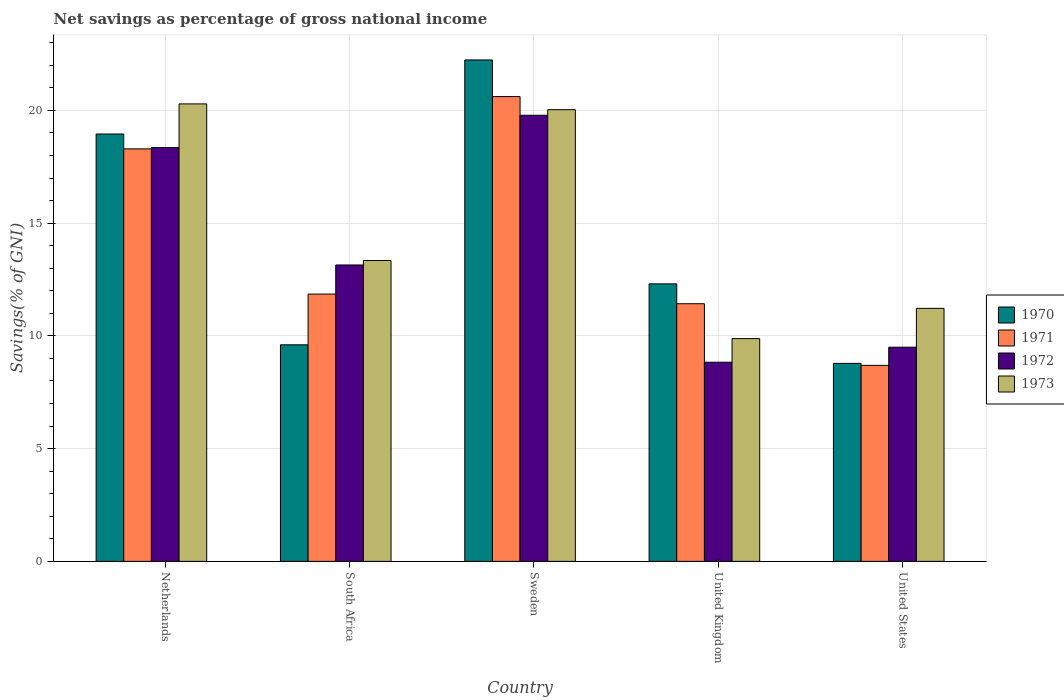How many groups of bars are there?
Keep it short and to the point. 5. Are the number of bars per tick equal to the number of legend labels?
Offer a very short reply. Yes. How many bars are there on the 5th tick from the left?
Ensure brevity in your answer.  4. What is the label of the 3rd group of bars from the left?
Provide a succinct answer. Sweden. In how many cases, is the number of bars for a given country not equal to the number of legend labels?
Make the answer very short. 0. What is the total savings in 1973 in Netherlands?
Keep it short and to the point. 20.29. Across all countries, what is the maximum total savings in 1970?
Ensure brevity in your answer.  22.24. Across all countries, what is the minimum total savings in 1973?
Your answer should be compact. 9.88. What is the total total savings in 1973 in the graph?
Ensure brevity in your answer.  74.76. What is the difference between the total savings in 1970 in South Africa and that in United Kingdom?
Ensure brevity in your answer.  -2.7. What is the difference between the total savings in 1971 in United States and the total savings in 1970 in Netherlands?
Provide a succinct answer. -10.26. What is the average total savings in 1970 per country?
Your answer should be very brief. 14.38. What is the difference between the total savings of/in 1970 and total savings of/in 1972 in United States?
Your answer should be compact. -0.72. In how many countries, is the total savings in 1971 greater than 2 %?
Make the answer very short. 5. What is the ratio of the total savings in 1970 in Sweden to that in United States?
Your answer should be very brief. 2.53. Is the total savings in 1973 in Sweden less than that in United States?
Your answer should be very brief. No. Is the difference between the total savings in 1970 in Sweden and United Kingdom greater than the difference between the total savings in 1972 in Sweden and United Kingdom?
Your answer should be very brief. No. What is the difference between the highest and the second highest total savings in 1972?
Your response must be concise. -1.43. What is the difference between the highest and the lowest total savings in 1973?
Ensure brevity in your answer.  10.41. In how many countries, is the total savings in 1973 greater than the average total savings in 1973 taken over all countries?
Provide a succinct answer. 2. Is the sum of the total savings in 1971 in Netherlands and United Kingdom greater than the maximum total savings in 1973 across all countries?
Keep it short and to the point. Yes. Is it the case that in every country, the sum of the total savings in 1973 and total savings in 1971 is greater than the sum of total savings in 1970 and total savings in 1972?
Your answer should be compact. No. What does the 3rd bar from the left in South Africa represents?
Ensure brevity in your answer.  1972. What does the 3rd bar from the right in Sweden represents?
Provide a succinct answer. 1971. Is it the case that in every country, the sum of the total savings in 1970 and total savings in 1973 is greater than the total savings in 1971?
Provide a short and direct response. Yes. Are all the bars in the graph horizontal?
Your response must be concise. No. How many countries are there in the graph?
Offer a very short reply. 5. What is the difference between two consecutive major ticks on the Y-axis?
Provide a short and direct response. 5. Does the graph contain any zero values?
Keep it short and to the point. No. Where does the legend appear in the graph?
Give a very brief answer. Center right. What is the title of the graph?
Make the answer very short. Net savings as percentage of gross national income. Does "1983" appear as one of the legend labels in the graph?
Your answer should be very brief. No. What is the label or title of the Y-axis?
Give a very brief answer. Savings(% of GNI). What is the Savings(% of GNI) in 1970 in Netherlands?
Give a very brief answer. 18.95. What is the Savings(% of GNI) in 1971 in Netherlands?
Give a very brief answer. 18.29. What is the Savings(% of GNI) in 1972 in Netherlands?
Provide a succinct answer. 18.35. What is the Savings(% of GNI) in 1973 in Netherlands?
Make the answer very short. 20.29. What is the Savings(% of GNI) in 1970 in South Africa?
Make the answer very short. 9.6. What is the Savings(% of GNI) of 1971 in South Africa?
Ensure brevity in your answer.  11.85. What is the Savings(% of GNI) in 1972 in South Africa?
Offer a terse response. 13.14. What is the Savings(% of GNI) of 1973 in South Africa?
Ensure brevity in your answer.  13.34. What is the Savings(% of GNI) in 1970 in Sweden?
Provide a succinct answer. 22.24. What is the Savings(% of GNI) in 1971 in Sweden?
Your answer should be compact. 20.61. What is the Savings(% of GNI) of 1972 in Sweden?
Keep it short and to the point. 19.78. What is the Savings(% of GNI) of 1973 in Sweden?
Keep it short and to the point. 20.03. What is the Savings(% of GNI) of 1970 in United Kingdom?
Your answer should be compact. 12.31. What is the Savings(% of GNI) in 1971 in United Kingdom?
Your answer should be compact. 11.43. What is the Savings(% of GNI) of 1972 in United Kingdom?
Provide a succinct answer. 8.83. What is the Savings(% of GNI) in 1973 in United Kingdom?
Give a very brief answer. 9.88. What is the Savings(% of GNI) in 1970 in United States?
Give a very brief answer. 8.78. What is the Savings(% of GNI) of 1971 in United States?
Your response must be concise. 8.69. What is the Savings(% of GNI) of 1972 in United States?
Offer a very short reply. 9.5. What is the Savings(% of GNI) of 1973 in United States?
Offer a very short reply. 11.22. Across all countries, what is the maximum Savings(% of GNI) of 1970?
Your response must be concise. 22.24. Across all countries, what is the maximum Savings(% of GNI) of 1971?
Provide a succinct answer. 20.61. Across all countries, what is the maximum Savings(% of GNI) of 1972?
Your response must be concise. 19.78. Across all countries, what is the maximum Savings(% of GNI) in 1973?
Your response must be concise. 20.29. Across all countries, what is the minimum Savings(% of GNI) of 1970?
Make the answer very short. 8.78. Across all countries, what is the minimum Savings(% of GNI) in 1971?
Give a very brief answer. 8.69. Across all countries, what is the minimum Savings(% of GNI) in 1972?
Provide a succinct answer. 8.83. Across all countries, what is the minimum Savings(% of GNI) in 1973?
Keep it short and to the point. 9.88. What is the total Savings(% of GNI) in 1970 in the graph?
Keep it short and to the point. 71.88. What is the total Savings(% of GNI) in 1971 in the graph?
Provide a short and direct response. 70.88. What is the total Savings(% of GNI) in 1972 in the graph?
Provide a succinct answer. 69.61. What is the total Savings(% of GNI) of 1973 in the graph?
Offer a very short reply. 74.76. What is the difference between the Savings(% of GNI) of 1970 in Netherlands and that in South Africa?
Keep it short and to the point. 9.35. What is the difference between the Savings(% of GNI) of 1971 in Netherlands and that in South Africa?
Your response must be concise. 6.44. What is the difference between the Savings(% of GNI) in 1972 in Netherlands and that in South Africa?
Give a very brief answer. 5.21. What is the difference between the Savings(% of GNI) in 1973 in Netherlands and that in South Africa?
Give a very brief answer. 6.95. What is the difference between the Savings(% of GNI) of 1970 in Netherlands and that in Sweden?
Your response must be concise. -3.28. What is the difference between the Savings(% of GNI) in 1971 in Netherlands and that in Sweden?
Offer a very short reply. -2.32. What is the difference between the Savings(% of GNI) in 1972 in Netherlands and that in Sweden?
Make the answer very short. -1.43. What is the difference between the Savings(% of GNI) of 1973 in Netherlands and that in Sweden?
Offer a very short reply. 0.26. What is the difference between the Savings(% of GNI) of 1970 in Netherlands and that in United Kingdom?
Provide a succinct answer. 6.65. What is the difference between the Savings(% of GNI) in 1971 in Netherlands and that in United Kingdom?
Offer a terse response. 6.87. What is the difference between the Savings(% of GNI) in 1972 in Netherlands and that in United Kingdom?
Give a very brief answer. 9.52. What is the difference between the Savings(% of GNI) of 1973 in Netherlands and that in United Kingdom?
Offer a very short reply. 10.41. What is the difference between the Savings(% of GNI) in 1970 in Netherlands and that in United States?
Provide a short and direct response. 10.17. What is the difference between the Savings(% of GNI) in 1971 in Netherlands and that in United States?
Your answer should be very brief. 9.6. What is the difference between the Savings(% of GNI) of 1972 in Netherlands and that in United States?
Offer a very short reply. 8.85. What is the difference between the Savings(% of GNI) of 1973 in Netherlands and that in United States?
Your answer should be compact. 9.07. What is the difference between the Savings(% of GNI) in 1970 in South Africa and that in Sweden?
Ensure brevity in your answer.  -12.63. What is the difference between the Savings(% of GNI) of 1971 in South Africa and that in Sweden?
Provide a short and direct response. -8.76. What is the difference between the Savings(% of GNI) of 1972 in South Africa and that in Sweden?
Give a very brief answer. -6.64. What is the difference between the Savings(% of GNI) in 1973 in South Africa and that in Sweden?
Your response must be concise. -6.69. What is the difference between the Savings(% of GNI) in 1970 in South Africa and that in United Kingdom?
Offer a very short reply. -2.7. What is the difference between the Savings(% of GNI) of 1971 in South Africa and that in United Kingdom?
Your answer should be very brief. 0.43. What is the difference between the Savings(% of GNI) of 1972 in South Africa and that in United Kingdom?
Your response must be concise. 4.31. What is the difference between the Savings(% of GNI) of 1973 in South Africa and that in United Kingdom?
Make the answer very short. 3.46. What is the difference between the Savings(% of GNI) in 1970 in South Africa and that in United States?
Provide a succinct answer. 0.82. What is the difference between the Savings(% of GNI) of 1971 in South Africa and that in United States?
Your answer should be compact. 3.16. What is the difference between the Savings(% of GNI) of 1972 in South Africa and that in United States?
Keep it short and to the point. 3.65. What is the difference between the Savings(% of GNI) in 1973 in South Africa and that in United States?
Your response must be concise. 2.12. What is the difference between the Savings(% of GNI) of 1970 in Sweden and that in United Kingdom?
Provide a short and direct response. 9.93. What is the difference between the Savings(% of GNI) in 1971 in Sweden and that in United Kingdom?
Give a very brief answer. 9.19. What is the difference between the Savings(% of GNI) of 1972 in Sweden and that in United Kingdom?
Offer a terse response. 10.95. What is the difference between the Savings(% of GNI) of 1973 in Sweden and that in United Kingdom?
Your response must be concise. 10.15. What is the difference between the Savings(% of GNI) of 1970 in Sweden and that in United States?
Offer a very short reply. 13.46. What is the difference between the Savings(% of GNI) of 1971 in Sweden and that in United States?
Keep it short and to the point. 11.92. What is the difference between the Savings(% of GNI) in 1972 in Sweden and that in United States?
Ensure brevity in your answer.  10.29. What is the difference between the Savings(% of GNI) of 1973 in Sweden and that in United States?
Your response must be concise. 8.81. What is the difference between the Savings(% of GNI) in 1970 in United Kingdom and that in United States?
Offer a terse response. 3.53. What is the difference between the Savings(% of GNI) in 1971 in United Kingdom and that in United States?
Give a very brief answer. 2.73. What is the difference between the Savings(% of GNI) of 1972 in United Kingdom and that in United States?
Ensure brevity in your answer.  -0.67. What is the difference between the Savings(% of GNI) in 1973 in United Kingdom and that in United States?
Provide a short and direct response. -1.34. What is the difference between the Savings(% of GNI) of 1970 in Netherlands and the Savings(% of GNI) of 1971 in South Africa?
Make the answer very short. 7.1. What is the difference between the Savings(% of GNI) of 1970 in Netherlands and the Savings(% of GNI) of 1972 in South Africa?
Your answer should be compact. 5.81. What is the difference between the Savings(% of GNI) of 1970 in Netherlands and the Savings(% of GNI) of 1973 in South Africa?
Keep it short and to the point. 5.61. What is the difference between the Savings(% of GNI) in 1971 in Netherlands and the Savings(% of GNI) in 1972 in South Africa?
Provide a short and direct response. 5.15. What is the difference between the Savings(% of GNI) of 1971 in Netherlands and the Savings(% of GNI) of 1973 in South Africa?
Your response must be concise. 4.95. What is the difference between the Savings(% of GNI) of 1972 in Netherlands and the Savings(% of GNI) of 1973 in South Africa?
Keep it short and to the point. 5.01. What is the difference between the Savings(% of GNI) of 1970 in Netherlands and the Savings(% of GNI) of 1971 in Sweden?
Keep it short and to the point. -1.66. What is the difference between the Savings(% of GNI) of 1970 in Netherlands and the Savings(% of GNI) of 1972 in Sweden?
Provide a short and direct response. -0.83. What is the difference between the Savings(% of GNI) of 1970 in Netherlands and the Savings(% of GNI) of 1973 in Sweden?
Ensure brevity in your answer.  -1.08. What is the difference between the Savings(% of GNI) of 1971 in Netherlands and the Savings(% of GNI) of 1972 in Sweden?
Keep it short and to the point. -1.49. What is the difference between the Savings(% of GNI) in 1971 in Netherlands and the Savings(% of GNI) in 1973 in Sweden?
Offer a terse response. -1.74. What is the difference between the Savings(% of GNI) in 1972 in Netherlands and the Savings(% of GNI) in 1973 in Sweden?
Provide a succinct answer. -1.68. What is the difference between the Savings(% of GNI) of 1970 in Netherlands and the Savings(% of GNI) of 1971 in United Kingdom?
Ensure brevity in your answer.  7.53. What is the difference between the Savings(% of GNI) of 1970 in Netherlands and the Savings(% of GNI) of 1972 in United Kingdom?
Make the answer very short. 10.12. What is the difference between the Savings(% of GNI) of 1970 in Netherlands and the Savings(% of GNI) of 1973 in United Kingdom?
Give a very brief answer. 9.07. What is the difference between the Savings(% of GNI) of 1971 in Netherlands and the Savings(% of GNI) of 1972 in United Kingdom?
Your answer should be very brief. 9.46. What is the difference between the Savings(% of GNI) in 1971 in Netherlands and the Savings(% of GNI) in 1973 in United Kingdom?
Provide a succinct answer. 8.42. What is the difference between the Savings(% of GNI) in 1972 in Netherlands and the Savings(% of GNI) in 1973 in United Kingdom?
Your answer should be very brief. 8.47. What is the difference between the Savings(% of GNI) of 1970 in Netherlands and the Savings(% of GNI) of 1971 in United States?
Ensure brevity in your answer.  10.26. What is the difference between the Savings(% of GNI) of 1970 in Netherlands and the Savings(% of GNI) of 1972 in United States?
Your answer should be very brief. 9.46. What is the difference between the Savings(% of GNI) of 1970 in Netherlands and the Savings(% of GNI) of 1973 in United States?
Your response must be concise. 7.73. What is the difference between the Savings(% of GNI) in 1971 in Netherlands and the Savings(% of GNI) in 1972 in United States?
Make the answer very short. 8.8. What is the difference between the Savings(% of GNI) of 1971 in Netherlands and the Savings(% of GNI) of 1973 in United States?
Your answer should be very brief. 7.07. What is the difference between the Savings(% of GNI) of 1972 in Netherlands and the Savings(% of GNI) of 1973 in United States?
Your response must be concise. 7.13. What is the difference between the Savings(% of GNI) in 1970 in South Africa and the Savings(% of GNI) in 1971 in Sweden?
Your answer should be very brief. -11.01. What is the difference between the Savings(% of GNI) in 1970 in South Africa and the Savings(% of GNI) in 1972 in Sweden?
Your answer should be compact. -10.18. What is the difference between the Savings(% of GNI) in 1970 in South Africa and the Savings(% of GNI) in 1973 in Sweden?
Your answer should be compact. -10.43. What is the difference between the Savings(% of GNI) of 1971 in South Africa and the Savings(% of GNI) of 1972 in Sweden?
Provide a succinct answer. -7.93. What is the difference between the Savings(% of GNI) in 1971 in South Africa and the Savings(% of GNI) in 1973 in Sweden?
Offer a very short reply. -8.18. What is the difference between the Savings(% of GNI) in 1972 in South Africa and the Savings(% of GNI) in 1973 in Sweden?
Keep it short and to the point. -6.89. What is the difference between the Savings(% of GNI) in 1970 in South Africa and the Savings(% of GNI) in 1971 in United Kingdom?
Offer a very short reply. -1.82. What is the difference between the Savings(% of GNI) in 1970 in South Africa and the Savings(% of GNI) in 1972 in United Kingdom?
Keep it short and to the point. 0.77. What is the difference between the Savings(% of GNI) in 1970 in South Africa and the Savings(% of GNI) in 1973 in United Kingdom?
Keep it short and to the point. -0.27. What is the difference between the Savings(% of GNI) in 1971 in South Africa and the Savings(% of GNI) in 1972 in United Kingdom?
Provide a succinct answer. 3.02. What is the difference between the Savings(% of GNI) of 1971 in South Africa and the Savings(% of GNI) of 1973 in United Kingdom?
Your answer should be very brief. 1.98. What is the difference between the Savings(% of GNI) in 1972 in South Africa and the Savings(% of GNI) in 1973 in United Kingdom?
Offer a terse response. 3.27. What is the difference between the Savings(% of GNI) of 1970 in South Africa and the Savings(% of GNI) of 1971 in United States?
Provide a succinct answer. 0.91. What is the difference between the Savings(% of GNI) in 1970 in South Africa and the Savings(% of GNI) in 1972 in United States?
Give a very brief answer. 0.11. What is the difference between the Savings(% of GNI) in 1970 in South Africa and the Savings(% of GNI) in 1973 in United States?
Provide a succinct answer. -1.62. What is the difference between the Savings(% of GNI) in 1971 in South Africa and the Savings(% of GNI) in 1972 in United States?
Keep it short and to the point. 2.36. What is the difference between the Savings(% of GNI) in 1971 in South Africa and the Savings(% of GNI) in 1973 in United States?
Keep it short and to the point. 0.63. What is the difference between the Savings(% of GNI) of 1972 in South Africa and the Savings(% of GNI) of 1973 in United States?
Ensure brevity in your answer.  1.92. What is the difference between the Savings(% of GNI) of 1970 in Sweden and the Savings(% of GNI) of 1971 in United Kingdom?
Offer a terse response. 10.81. What is the difference between the Savings(% of GNI) in 1970 in Sweden and the Savings(% of GNI) in 1972 in United Kingdom?
Make the answer very short. 13.41. What is the difference between the Savings(% of GNI) of 1970 in Sweden and the Savings(% of GNI) of 1973 in United Kingdom?
Keep it short and to the point. 12.36. What is the difference between the Savings(% of GNI) of 1971 in Sweden and the Savings(% of GNI) of 1972 in United Kingdom?
Provide a short and direct response. 11.78. What is the difference between the Savings(% of GNI) of 1971 in Sweden and the Savings(% of GNI) of 1973 in United Kingdom?
Offer a very short reply. 10.73. What is the difference between the Savings(% of GNI) of 1972 in Sweden and the Savings(% of GNI) of 1973 in United Kingdom?
Give a very brief answer. 9.91. What is the difference between the Savings(% of GNI) in 1970 in Sweden and the Savings(% of GNI) in 1971 in United States?
Ensure brevity in your answer.  13.54. What is the difference between the Savings(% of GNI) in 1970 in Sweden and the Savings(% of GNI) in 1972 in United States?
Give a very brief answer. 12.74. What is the difference between the Savings(% of GNI) of 1970 in Sweden and the Savings(% of GNI) of 1973 in United States?
Give a very brief answer. 11.02. What is the difference between the Savings(% of GNI) in 1971 in Sweden and the Savings(% of GNI) in 1972 in United States?
Keep it short and to the point. 11.12. What is the difference between the Savings(% of GNI) in 1971 in Sweden and the Savings(% of GNI) in 1973 in United States?
Keep it short and to the point. 9.39. What is the difference between the Savings(% of GNI) of 1972 in Sweden and the Savings(% of GNI) of 1973 in United States?
Offer a very short reply. 8.56. What is the difference between the Savings(% of GNI) of 1970 in United Kingdom and the Savings(% of GNI) of 1971 in United States?
Make the answer very short. 3.62. What is the difference between the Savings(% of GNI) of 1970 in United Kingdom and the Savings(% of GNI) of 1972 in United States?
Provide a short and direct response. 2.81. What is the difference between the Savings(% of GNI) of 1970 in United Kingdom and the Savings(% of GNI) of 1973 in United States?
Make the answer very short. 1.09. What is the difference between the Savings(% of GNI) of 1971 in United Kingdom and the Savings(% of GNI) of 1972 in United States?
Offer a very short reply. 1.93. What is the difference between the Savings(% of GNI) in 1971 in United Kingdom and the Savings(% of GNI) in 1973 in United States?
Provide a succinct answer. 0.2. What is the difference between the Savings(% of GNI) in 1972 in United Kingdom and the Savings(% of GNI) in 1973 in United States?
Your response must be concise. -2.39. What is the average Savings(% of GNI) of 1970 per country?
Offer a terse response. 14.38. What is the average Savings(% of GNI) in 1971 per country?
Provide a succinct answer. 14.18. What is the average Savings(% of GNI) of 1972 per country?
Make the answer very short. 13.92. What is the average Savings(% of GNI) in 1973 per country?
Your answer should be compact. 14.95. What is the difference between the Savings(% of GNI) in 1970 and Savings(% of GNI) in 1971 in Netherlands?
Offer a terse response. 0.66. What is the difference between the Savings(% of GNI) of 1970 and Savings(% of GNI) of 1972 in Netherlands?
Offer a terse response. 0.6. What is the difference between the Savings(% of GNI) in 1970 and Savings(% of GNI) in 1973 in Netherlands?
Your answer should be compact. -1.33. What is the difference between the Savings(% of GNI) of 1971 and Savings(% of GNI) of 1972 in Netherlands?
Give a very brief answer. -0.06. What is the difference between the Savings(% of GNI) of 1971 and Savings(% of GNI) of 1973 in Netherlands?
Your answer should be very brief. -1.99. What is the difference between the Savings(% of GNI) of 1972 and Savings(% of GNI) of 1973 in Netherlands?
Make the answer very short. -1.94. What is the difference between the Savings(% of GNI) of 1970 and Savings(% of GNI) of 1971 in South Africa?
Give a very brief answer. -2.25. What is the difference between the Savings(% of GNI) of 1970 and Savings(% of GNI) of 1972 in South Africa?
Give a very brief answer. -3.54. What is the difference between the Savings(% of GNI) in 1970 and Savings(% of GNI) in 1973 in South Africa?
Your answer should be compact. -3.74. What is the difference between the Savings(% of GNI) in 1971 and Savings(% of GNI) in 1972 in South Africa?
Ensure brevity in your answer.  -1.29. What is the difference between the Savings(% of GNI) of 1971 and Savings(% of GNI) of 1973 in South Africa?
Ensure brevity in your answer.  -1.49. What is the difference between the Savings(% of GNI) in 1972 and Savings(% of GNI) in 1973 in South Africa?
Ensure brevity in your answer.  -0.2. What is the difference between the Savings(% of GNI) in 1970 and Savings(% of GNI) in 1971 in Sweden?
Make the answer very short. 1.62. What is the difference between the Savings(% of GNI) of 1970 and Savings(% of GNI) of 1972 in Sweden?
Keep it short and to the point. 2.45. What is the difference between the Savings(% of GNI) of 1970 and Savings(% of GNI) of 1973 in Sweden?
Offer a terse response. 2.21. What is the difference between the Savings(% of GNI) in 1971 and Savings(% of GNI) in 1972 in Sweden?
Provide a succinct answer. 0.83. What is the difference between the Savings(% of GNI) of 1971 and Savings(% of GNI) of 1973 in Sweden?
Offer a very short reply. 0.58. What is the difference between the Savings(% of GNI) of 1972 and Savings(% of GNI) of 1973 in Sweden?
Your answer should be compact. -0.25. What is the difference between the Savings(% of GNI) of 1970 and Savings(% of GNI) of 1971 in United Kingdom?
Make the answer very short. 0.88. What is the difference between the Savings(% of GNI) in 1970 and Savings(% of GNI) in 1972 in United Kingdom?
Give a very brief answer. 3.48. What is the difference between the Savings(% of GNI) of 1970 and Savings(% of GNI) of 1973 in United Kingdom?
Your answer should be very brief. 2.43. What is the difference between the Savings(% of GNI) in 1971 and Savings(% of GNI) in 1972 in United Kingdom?
Keep it short and to the point. 2.59. What is the difference between the Savings(% of GNI) of 1971 and Savings(% of GNI) of 1973 in United Kingdom?
Ensure brevity in your answer.  1.55. What is the difference between the Savings(% of GNI) in 1972 and Savings(% of GNI) in 1973 in United Kingdom?
Offer a very short reply. -1.05. What is the difference between the Savings(% of GNI) of 1970 and Savings(% of GNI) of 1971 in United States?
Your answer should be compact. 0.09. What is the difference between the Savings(% of GNI) in 1970 and Savings(% of GNI) in 1972 in United States?
Ensure brevity in your answer.  -0.72. What is the difference between the Savings(% of GNI) in 1970 and Savings(% of GNI) in 1973 in United States?
Offer a very short reply. -2.44. What is the difference between the Savings(% of GNI) of 1971 and Savings(% of GNI) of 1972 in United States?
Your answer should be very brief. -0.81. What is the difference between the Savings(% of GNI) of 1971 and Savings(% of GNI) of 1973 in United States?
Keep it short and to the point. -2.53. What is the difference between the Savings(% of GNI) in 1972 and Savings(% of GNI) in 1973 in United States?
Your answer should be compact. -1.72. What is the ratio of the Savings(% of GNI) of 1970 in Netherlands to that in South Africa?
Make the answer very short. 1.97. What is the ratio of the Savings(% of GNI) of 1971 in Netherlands to that in South Africa?
Keep it short and to the point. 1.54. What is the ratio of the Savings(% of GNI) of 1972 in Netherlands to that in South Africa?
Make the answer very short. 1.4. What is the ratio of the Savings(% of GNI) of 1973 in Netherlands to that in South Africa?
Your response must be concise. 1.52. What is the ratio of the Savings(% of GNI) of 1970 in Netherlands to that in Sweden?
Make the answer very short. 0.85. What is the ratio of the Savings(% of GNI) in 1971 in Netherlands to that in Sweden?
Ensure brevity in your answer.  0.89. What is the ratio of the Savings(% of GNI) in 1972 in Netherlands to that in Sweden?
Provide a succinct answer. 0.93. What is the ratio of the Savings(% of GNI) in 1973 in Netherlands to that in Sweden?
Provide a succinct answer. 1.01. What is the ratio of the Savings(% of GNI) of 1970 in Netherlands to that in United Kingdom?
Keep it short and to the point. 1.54. What is the ratio of the Savings(% of GNI) of 1971 in Netherlands to that in United Kingdom?
Provide a short and direct response. 1.6. What is the ratio of the Savings(% of GNI) of 1972 in Netherlands to that in United Kingdom?
Offer a terse response. 2.08. What is the ratio of the Savings(% of GNI) in 1973 in Netherlands to that in United Kingdom?
Provide a succinct answer. 2.05. What is the ratio of the Savings(% of GNI) of 1970 in Netherlands to that in United States?
Keep it short and to the point. 2.16. What is the ratio of the Savings(% of GNI) in 1971 in Netherlands to that in United States?
Ensure brevity in your answer.  2.1. What is the ratio of the Savings(% of GNI) of 1972 in Netherlands to that in United States?
Your answer should be compact. 1.93. What is the ratio of the Savings(% of GNI) of 1973 in Netherlands to that in United States?
Offer a very short reply. 1.81. What is the ratio of the Savings(% of GNI) in 1970 in South Africa to that in Sweden?
Provide a short and direct response. 0.43. What is the ratio of the Savings(% of GNI) of 1971 in South Africa to that in Sweden?
Give a very brief answer. 0.58. What is the ratio of the Savings(% of GNI) in 1972 in South Africa to that in Sweden?
Make the answer very short. 0.66. What is the ratio of the Savings(% of GNI) of 1973 in South Africa to that in Sweden?
Your answer should be very brief. 0.67. What is the ratio of the Savings(% of GNI) in 1970 in South Africa to that in United Kingdom?
Provide a succinct answer. 0.78. What is the ratio of the Savings(% of GNI) in 1971 in South Africa to that in United Kingdom?
Your response must be concise. 1.04. What is the ratio of the Savings(% of GNI) in 1972 in South Africa to that in United Kingdom?
Give a very brief answer. 1.49. What is the ratio of the Savings(% of GNI) in 1973 in South Africa to that in United Kingdom?
Give a very brief answer. 1.35. What is the ratio of the Savings(% of GNI) of 1970 in South Africa to that in United States?
Provide a succinct answer. 1.09. What is the ratio of the Savings(% of GNI) in 1971 in South Africa to that in United States?
Offer a very short reply. 1.36. What is the ratio of the Savings(% of GNI) of 1972 in South Africa to that in United States?
Offer a terse response. 1.38. What is the ratio of the Savings(% of GNI) of 1973 in South Africa to that in United States?
Offer a very short reply. 1.19. What is the ratio of the Savings(% of GNI) of 1970 in Sweden to that in United Kingdom?
Your response must be concise. 1.81. What is the ratio of the Savings(% of GNI) in 1971 in Sweden to that in United Kingdom?
Offer a very short reply. 1.8. What is the ratio of the Savings(% of GNI) of 1972 in Sweden to that in United Kingdom?
Make the answer very short. 2.24. What is the ratio of the Savings(% of GNI) in 1973 in Sweden to that in United Kingdom?
Provide a short and direct response. 2.03. What is the ratio of the Savings(% of GNI) of 1970 in Sweden to that in United States?
Provide a succinct answer. 2.53. What is the ratio of the Savings(% of GNI) in 1971 in Sweden to that in United States?
Your response must be concise. 2.37. What is the ratio of the Savings(% of GNI) in 1972 in Sweden to that in United States?
Provide a succinct answer. 2.08. What is the ratio of the Savings(% of GNI) in 1973 in Sweden to that in United States?
Offer a terse response. 1.79. What is the ratio of the Savings(% of GNI) of 1970 in United Kingdom to that in United States?
Keep it short and to the point. 1.4. What is the ratio of the Savings(% of GNI) of 1971 in United Kingdom to that in United States?
Provide a succinct answer. 1.31. What is the ratio of the Savings(% of GNI) in 1972 in United Kingdom to that in United States?
Offer a terse response. 0.93. What is the ratio of the Savings(% of GNI) in 1973 in United Kingdom to that in United States?
Your answer should be compact. 0.88. What is the difference between the highest and the second highest Savings(% of GNI) of 1970?
Offer a very short reply. 3.28. What is the difference between the highest and the second highest Savings(% of GNI) of 1971?
Offer a very short reply. 2.32. What is the difference between the highest and the second highest Savings(% of GNI) in 1972?
Your answer should be very brief. 1.43. What is the difference between the highest and the second highest Savings(% of GNI) in 1973?
Keep it short and to the point. 0.26. What is the difference between the highest and the lowest Savings(% of GNI) in 1970?
Offer a very short reply. 13.46. What is the difference between the highest and the lowest Savings(% of GNI) in 1971?
Offer a very short reply. 11.92. What is the difference between the highest and the lowest Savings(% of GNI) of 1972?
Offer a terse response. 10.95. What is the difference between the highest and the lowest Savings(% of GNI) in 1973?
Your response must be concise. 10.41. 